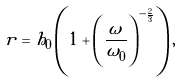<formula> <loc_0><loc_0><loc_500><loc_500>r = h _ { 0 } \left ( 1 + \left ( \frac { \omega } { \omega _ { 0 } } \right ) ^ { - \frac { 2 } { 3 } } \right ) ,</formula> 